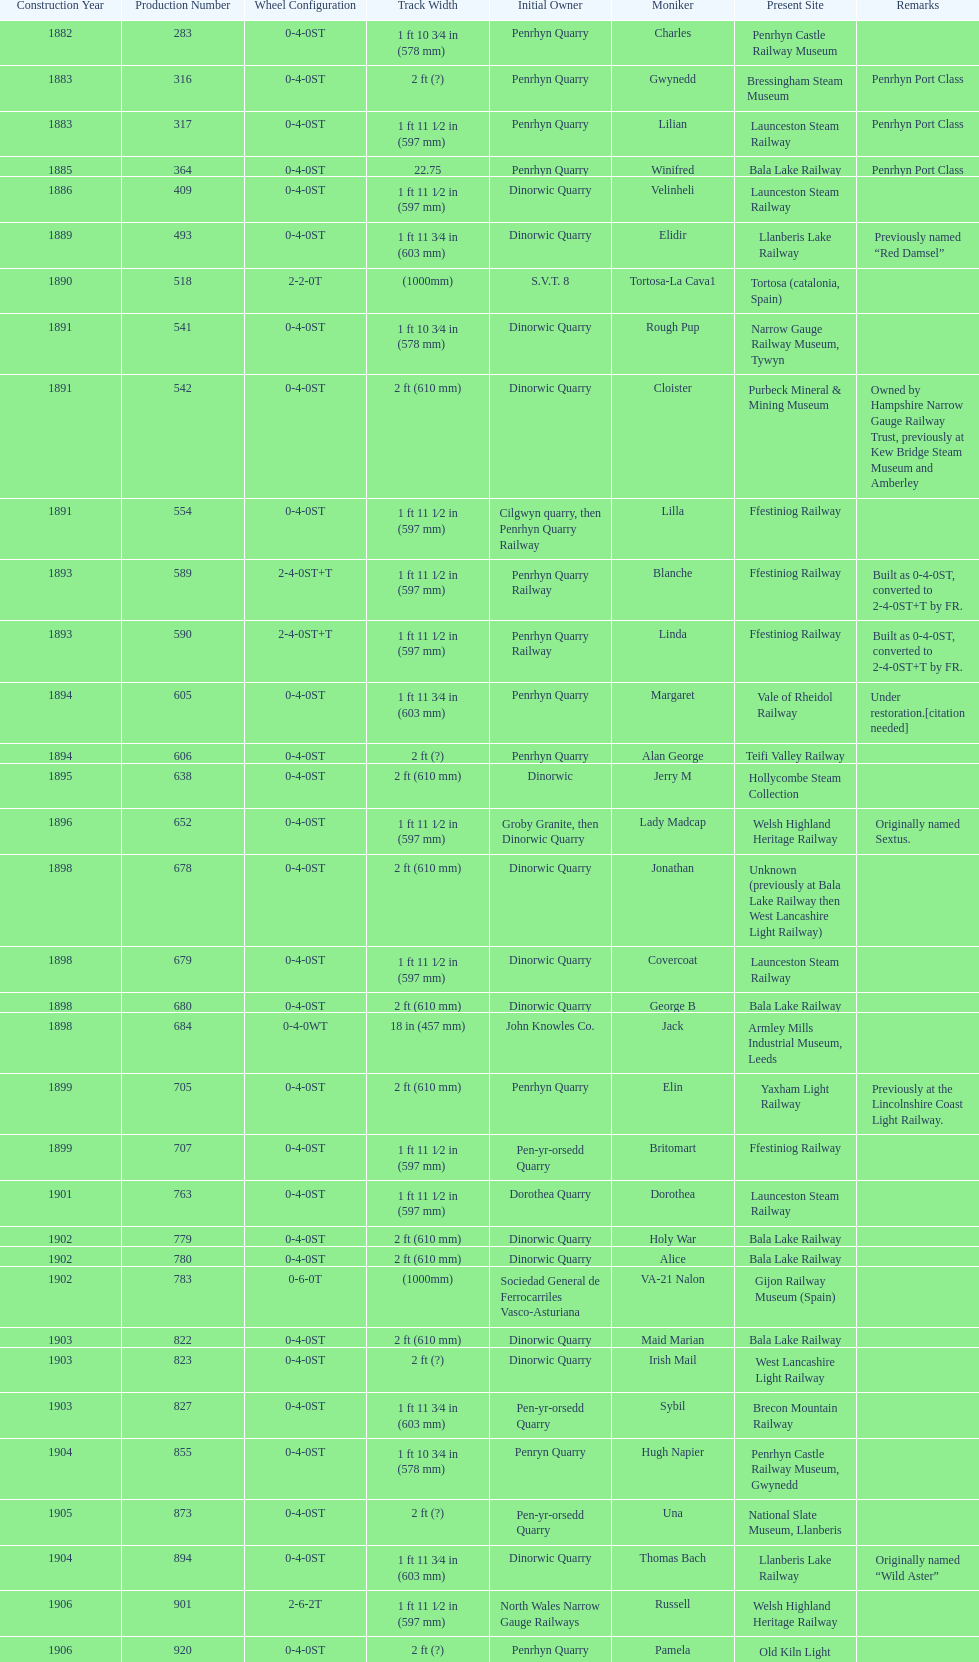Would you be able to parse every entry in this table? {'header': ['Construction Year', 'Production Number', 'Wheel Configuration', 'Track Width', 'Initial Owner', 'Moniker', 'Present Site', 'Remarks'], 'rows': [['1882', '283', '0-4-0ST', '1\xa0ft 10\xa03⁄4\xa0in (578\xa0mm)', 'Penrhyn Quarry', 'Charles', 'Penrhyn Castle Railway Museum', ''], ['1883', '316', '0-4-0ST', '2\xa0ft (?)', 'Penrhyn Quarry', 'Gwynedd', 'Bressingham Steam Museum', 'Penrhyn Port Class'], ['1883', '317', '0-4-0ST', '1\xa0ft 11\xa01⁄2\xa0in (597\xa0mm)', 'Penrhyn Quarry', 'Lilian', 'Launceston Steam Railway', 'Penrhyn Port Class'], ['1885', '364', '0-4-0ST', '22.75', 'Penrhyn Quarry', 'Winifred', 'Bala Lake Railway', 'Penrhyn Port Class'], ['1886', '409', '0-4-0ST', '1\xa0ft 11\xa01⁄2\xa0in (597\xa0mm)', 'Dinorwic Quarry', 'Velinheli', 'Launceston Steam Railway', ''], ['1889', '493', '0-4-0ST', '1\xa0ft 11\xa03⁄4\xa0in (603\xa0mm)', 'Dinorwic Quarry', 'Elidir', 'Llanberis Lake Railway', 'Previously named “Red Damsel”'], ['1890', '518', '2-2-0T', '(1000mm)', 'S.V.T. 8', 'Tortosa-La Cava1', 'Tortosa (catalonia, Spain)', ''], ['1891', '541', '0-4-0ST', '1\xa0ft 10\xa03⁄4\xa0in (578\xa0mm)', 'Dinorwic Quarry', 'Rough Pup', 'Narrow Gauge Railway Museum, Tywyn', ''], ['1891', '542', '0-4-0ST', '2\xa0ft (610\xa0mm)', 'Dinorwic Quarry', 'Cloister', 'Purbeck Mineral & Mining Museum', 'Owned by Hampshire Narrow Gauge Railway Trust, previously at Kew Bridge Steam Museum and Amberley'], ['1891', '554', '0-4-0ST', '1\xa0ft 11\xa01⁄2\xa0in (597\xa0mm)', 'Cilgwyn quarry, then Penrhyn Quarry Railway', 'Lilla', 'Ffestiniog Railway', ''], ['1893', '589', '2-4-0ST+T', '1\xa0ft 11\xa01⁄2\xa0in (597\xa0mm)', 'Penrhyn Quarry Railway', 'Blanche', 'Ffestiniog Railway', 'Built as 0-4-0ST, converted to 2-4-0ST+T by FR.'], ['1893', '590', '2-4-0ST+T', '1\xa0ft 11\xa01⁄2\xa0in (597\xa0mm)', 'Penrhyn Quarry Railway', 'Linda', 'Ffestiniog Railway', 'Built as 0-4-0ST, converted to 2-4-0ST+T by FR.'], ['1894', '605', '0-4-0ST', '1\xa0ft 11\xa03⁄4\xa0in (603\xa0mm)', 'Penrhyn Quarry', 'Margaret', 'Vale of Rheidol Railway', 'Under restoration.[citation needed]'], ['1894', '606', '0-4-0ST', '2\xa0ft (?)', 'Penrhyn Quarry', 'Alan George', 'Teifi Valley Railway', ''], ['1895', '638', '0-4-0ST', '2\xa0ft (610\xa0mm)', 'Dinorwic', 'Jerry M', 'Hollycombe Steam Collection', ''], ['1896', '652', '0-4-0ST', '1\xa0ft 11\xa01⁄2\xa0in (597\xa0mm)', 'Groby Granite, then Dinorwic Quarry', 'Lady Madcap', 'Welsh Highland Heritage Railway', 'Originally named Sextus.'], ['1898', '678', '0-4-0ST', '2\xa0ft (610\xa0mm)', 'Dinorwic Quarry', 'Jonathan', 'Unknown (previously at Bala Lake Railway then West Lancashire Light Railway)', ''], ['1898', '679', '0-4-0ST', '1\xa0ft 11\xa01⁄2\xa0in (597\xa0mm)', 'Dinorwic Quarry', 'Covercoat', 'Launceston Steam Railway', ''], ['1898', '680', '0-4-0ST', '2\xa0ft (610\xa0mm)', 'Dinorwic Quarry', 'George B', 'Bala Lake Railway', ''], ['1898', '684', '0-4-0WT', '18\xa0in (457\xa0mm)', 'John Knowles Co.', 'Jack', 'Armley Mills Industrial Museum, Leeds', ''], ['1899', '705', '0-4-0ST', '2\xa0ft (610\xa0mm)', 'Penrhyn Quarry', 'Elin', 'Yaxham Light Railway', 'Previously at the Lincolnshire Coast Light Railway.'], ['1899', '707', '0-4-0ST', '1\xa0ft 11\xa01⁄2\xa0in (597\xa0mm)', 'Pen-yr-orsedd Quarry', 'Britomart', 'Ffestiniog Railway', ''], ['1901', '763', '0-4-0ST', '1\xa0ft 11\xa01⁄2\xa0in (597\xa0mm)', 'Dorothea Quarry', 'Dorothea', 'Launceston Steam Railway', ''], ['1902', '779', '0-4-0ST', '2\xa0ft (610\xa0mm)', 'Dinorwic Quarry', 'Holy War', 'Bala Lake Railway', ''], ['1902', '780', '0-4-0ST', '2\xa0ft (610\xa0mm)', 'Dinorwic Quarry', 'Alice', 'Bala Lake Railway', ''], ['1902', '783', '0-6-0T', '(1000mm)', 'Sociedad General de Ferrocarriles Vasco-Asturiana', 'VA-21 Nalon', 'Gijon Railway Museum (Spain)', ''], ['1903', '822', '0-4-0ST', '2\xa0ft (610\xa0mm)', 'Dinorwic Quarry', 'Maid Marian', 'Bala Lake Railway', ''], ['1903', '823', '0-4-0ST', '2\xa0ft (?)', 'Dinorwic Quarry', 'Irish Mail', 'West Lancashire Light Railway', ''], ['1903', '827', '0-4-0ST', '1\xa0ft 11\xa03⁄4\xa0in (603\xa0mm)', 'Pen-yr-orsedd Quarry', 'Sybil', 'Brecon Mountain Railway', ''], ['1904', '855', '0-4-0ST', '1\xa0ft 10\xa03⁄4\xa0in (578\xa0mm)', 'Penryn Quarry', 'Hugh Napier', 'Penrhyn Castle Railway Museum, Gwynedd', ''], ['1905', '873', '0-4-0ST', '2\xa0ft (?)', 'Pen-yr-orsedd Quarry', 'Una', 'National Slate Museum, Llanberis', ''], ['1904', '894', '0-4-0ST', '1\xa0ft 11\xa03⁄4\xa0in (603\xa0mm)', 'Dinorwic Quarry', 'Thomas Bach', 'Llanberis Lake Railway', 'Originally named “Wild Aster”'], ['1906', '901', '2-6-2T', '1\xa0ft 11\xa01⁄2\xa0in (597\xa0mm)', 'North Wales Narrow Gauge Railways', 'Russell', 'Welsh Highland Heritage Railway', ''], ['1906', '920', '0-4-0ST', '2\xa0ft (?)', 'Penrhyn Quarry', 'Pamela', 'Old Kiln Light Railway', ''], ['1909', '994', '0-4-0ST', '2\xa0ft (?)', 'Penrhyn Quarry', 'Bill Harvey', 'Bressingham Steam Museum', 'previously George Sholto'], ['1918', '1312', '4-6-0T', '1\xa0ft\xa011\xa01⁄2\xa0in (597\xa0mm)', 'British War Department\\nEFOP #203', '---', 'Pampas Safari, Gravataí, RS, Brazil', '[citation needed]'], ['1918\\nor\\n1921?', '1313', '0-6-2T', '3\xa0ft\xa03\xa03⁄8\xa0in (1,000\xa0mm)', 'British War Department\\nUsina Leão Utinga #1\\nUsina Laginha #1', '---', 'Usina Laginha, União dos Palmares, AL, Brazil', '[citation needed]'], ['1920', '1404', '0-4-0WT', '18\xa0in (457\xa0mm)', 'John Knowles Co.', 'Gwen', 'Richard Farmer current owner, Northridge, California, USA', ''], ['1922', '1429', '0-4-0ST', '2\xa0ft (610\xa0mm)', 'Dinorwic', 'Lady Joan', 'Bredgar and Wormshill Light Railway', ''], ['1922', '1430', '0-4-0ST', '1\xa0ft 11\xa03⁄4\xa0in (603\xa0mm)', 'Dinorwic Quarry', 'Dolbadarn', 'Llanberis Lake Railway', ''], ['1937', '1859', '0-4-2T', '2\xa0ft (?)', 'Umtwalumi Valley Estate, Natal', '16 Carlisle', 'South Tynedale Railway', ''], ['1940', '2075', '0-4-2T', '2\xa0ft (?)', 'Chaka’s Kraal Sugar Estates, Natal', 'Chaka’s Kraal No. 6', 'North Gloucestershire Railway', ''], ['1954', '3815', '2-6-2T', '2\xa0ft 6\xa0in (762\xa0mm)', 'Sierra Leone Government Railway', '14', 'Welshpool and Llanfair Light Railway', ''], ['1971', '3902', '0-4-2ST', '2\xa0ft (610\xa0mm)', 'Trangkil Sugar Mill, Indonesia', 'Trangkil No.4', 'Statfold Barn Railway', 'Converted from 750\xa0mm (2\xa0ft\xa05\xa01⁄2\xa0in) gauge. Last steam locomotive to be built by Hunslet, and the last industrial steam locomotive built in Britain.']]} What is the difference in gauge between works numbers 541 and 542? 32 mm. 